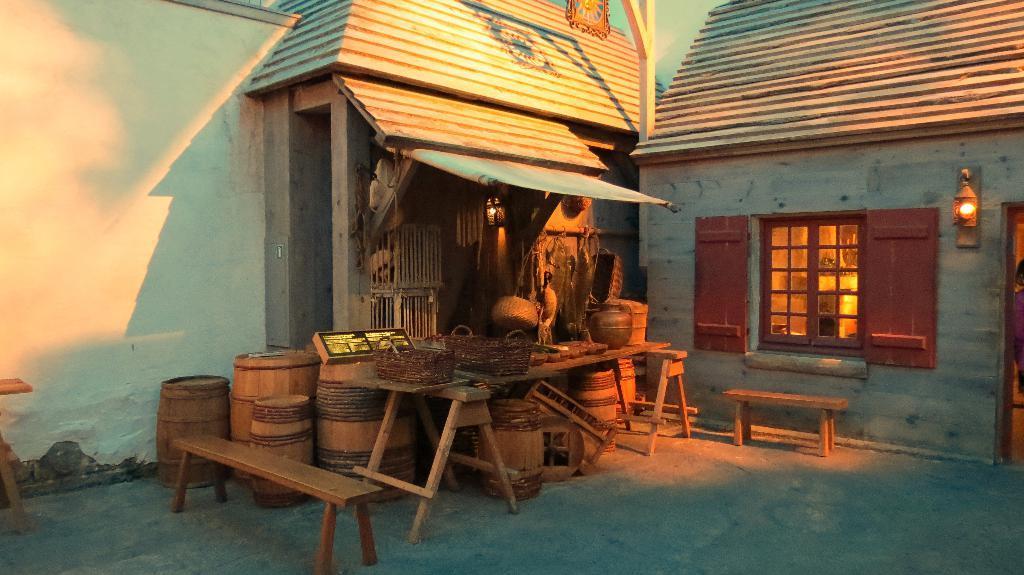In one or two sentences, can you explain what this image depicts? In this image I can see few tables. On the table I can see the baskets and some objects. To the side there are many barrels and the benches. In the background I can see the house and I can also see the window and the light to the wall. 